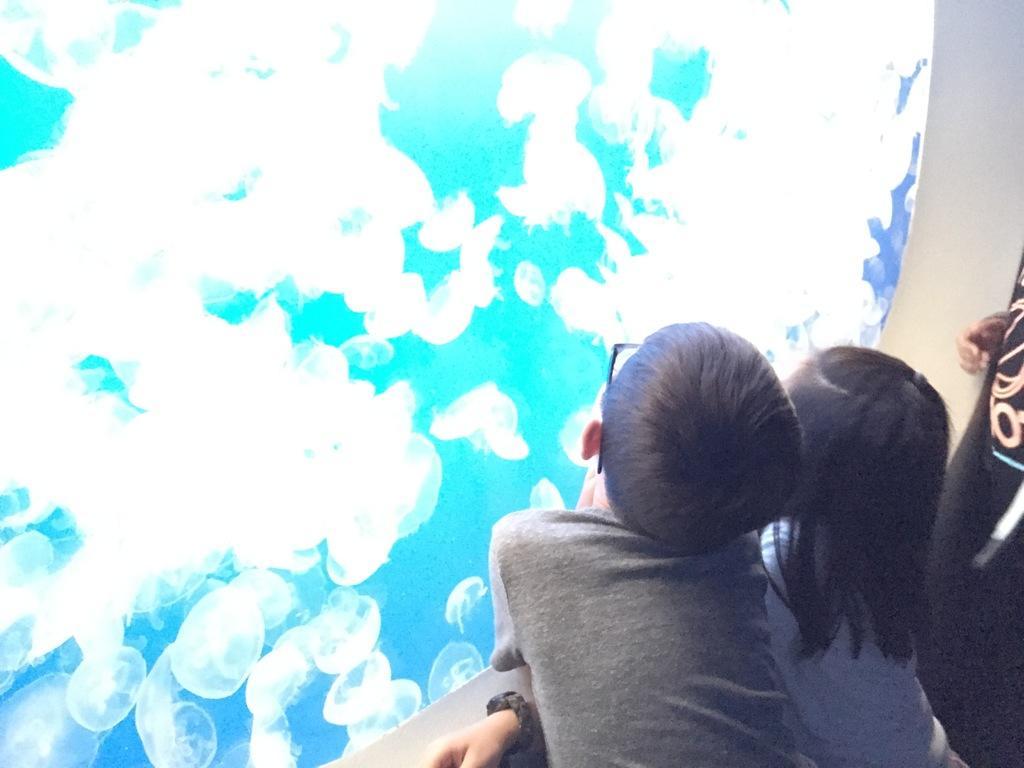Please provide a concise description of this image. In this image we can see one boy and one girl is standing and watching inside the aquarium. 